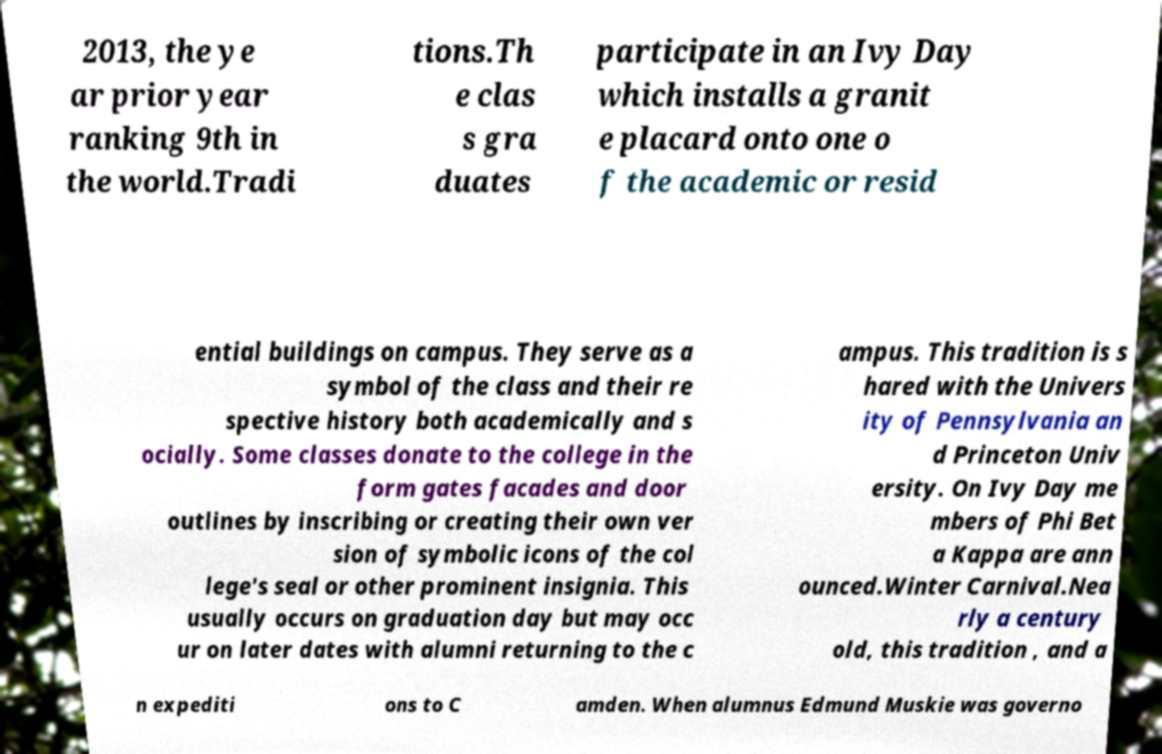There's text embedded in this image that I need extracted. Can you transcribe it verbatim? 2013, the ye ar prior year ranking 9th in the world.Tradi tions.Th e clas s gra duates participate in an Ivy Day which installs a granit e placard onto one o f the academic or resid ential buildings on campus. They serve as a symbol of the class and their re spective history both academically and s ocially. Some classes donate to the college in the form gates facades and door outlines by inscribing or creating their own ver sion of symbolic icons of the col lege's seal or other prominent insignia. This usually occurs on graduation day but may occ ur on later dates with alumni returning to the c ampus. This tradition is s hared with the Univers ity of Pennsylvania an d Princeton Univ ersity. On Ivy Day me mbers of Phi Bet a Kappa are ann ounced.Winter Carnival.Nea rly a century old, this tradition , and a n expediti ons to C amden. When alumnus Edmund Muskie was governo 